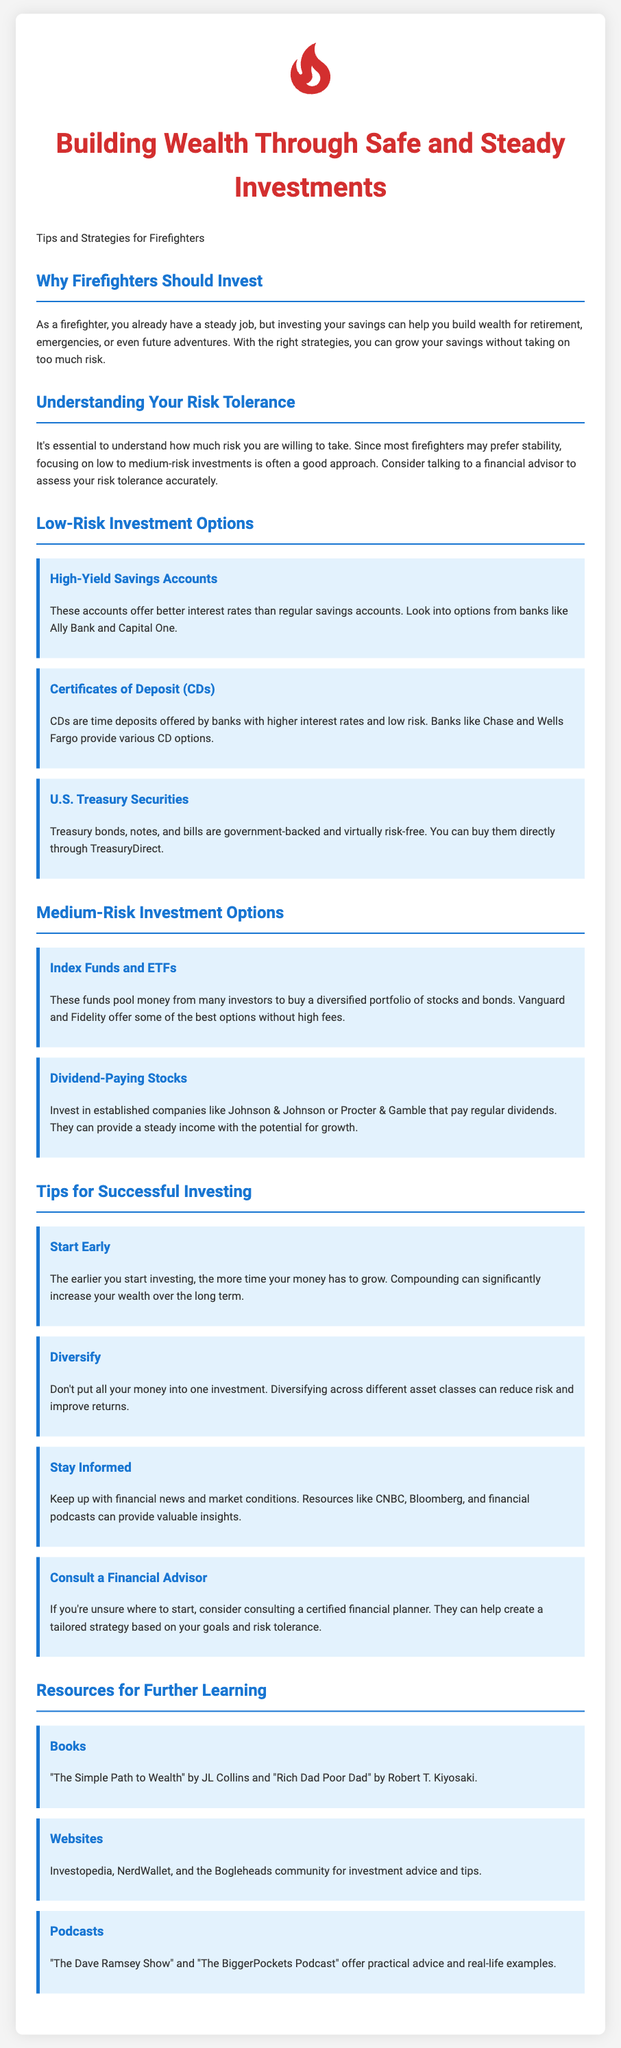What is the main focus of this flyer? The main focus of the flyer is on building wealth through safe and steady investments specifically for firefighters.
Answer: Building wealth through safe and steady investments What are two examples of low-risk investment options mentioned? The document lists High-Yield Savings Accounts and Certificates of Deposit as examples of low-risk investments.
Answer: High-Yield Savings Accounts and Certificates of Deposit What does the flyer recommend for understanding personal investment risk? The flyer recommends talking to a financial advisor to assess risk tolerance accurately.
Answer: Talk to a financial advisor Which book is suggested for further learning about investment? The flyer recommends "The Simple Path to Wealth" by JL Collins for further learning.
Answer: The Simple Path to Wealth What is the benefit of starting to invest early? The document states that starting early allows more time for money to grow due to compound interest.
Answer: More time for money to grow What is one of the recommended medium-risk investment options? The flyer mentions Index Funds and ETFs as a medium-risk investment option.
Answer: Index Funds and ETFs What is a resource mentioned for financial news updates? The document suggests CNBC as a resource for keeping up with financial news.
Answer: CNBC What is the significance of diversifying investments? The flyer states that diversifying across different asset classes can reduce risk and improve returns.
Answer: Reduce risk and improve returns 